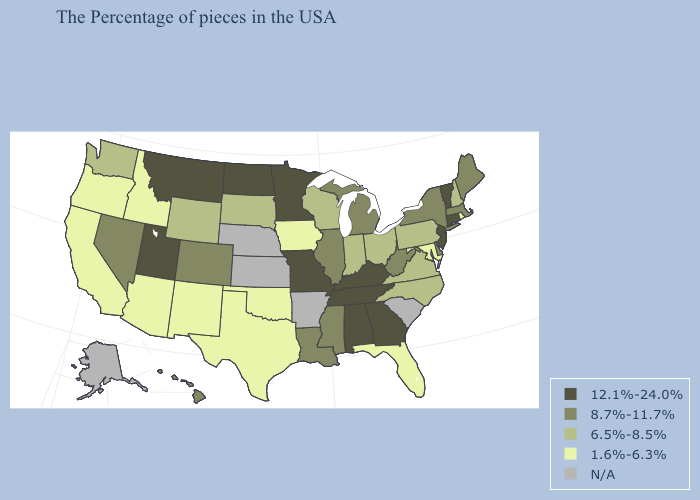Name the states that have a value in the range 6.5%-8.5%?
Short answer required. New Hampshire, Pennsylvania, Virginia, North Carolina, Ohio, Indiana, Wisconsin, South Dakota, Wyoming, Washington. Name the states that have a value in the range 12.1%-24.0%?
Quick response, please. Vermont, Connecticut, New Jersey, Georgia, Kentucky, Alabama, Tennessee, Missouri, Minnesota, North Dakota, Utah, Montana. Which states hav the highest value in the South?
Answer briefly. Georgia, Kentucky, Alabama, Tennessee. Which states hav the highest value in the Northeast?
Quick response, please. Vermont, Connecticut, New Jersey. Does Delaware have the lowest value in the South?
Short answer required. No. What is the lowest value in the USA?
Write a very short answer. 1.6%-6.3%. Does California have the lowest value in the USA?
Short answer required. Yes. What is the value of Connecticut?
Short answer required. 12.1%-24.0%. Among the states that border Montana , does Wyoming have the highest value?
Write a very short answer. No. What is the highest value in states that border New Mexico?
Write a very short answer. 12.1%-24.0%. Which states hav the highest value in the West?
Answer briefly. Utah, Montana. Among the states that border Maine , which have the highest value?
Short answer required. New Hampshire. What is the lowest value in the West?
Concise answer only. 1.6%-6.3%. Name the states that have a value in the range N/A?
Keep it brief. South Carolina, Arkansas, Kansas, Nebraska, Alaska. 